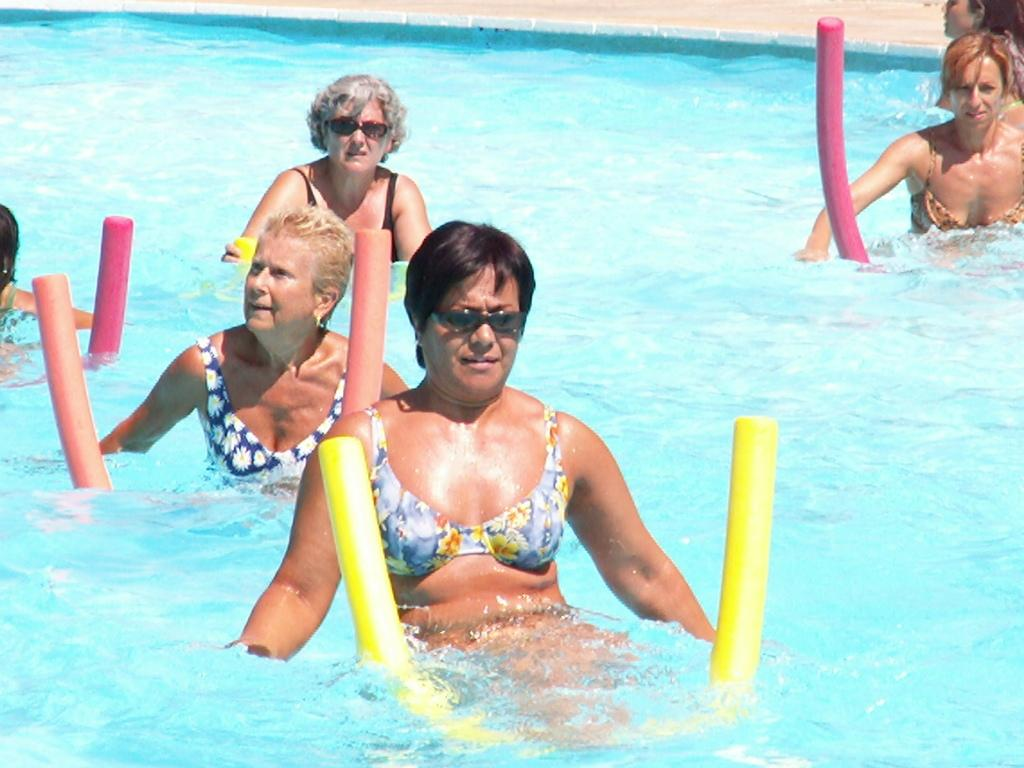What is the main element present in the image? There is water in the image. Are there any people in the image? Yes, there are people near the water. What other objects can be seen in the image? There are colored objects in the image. What is the surface on which the people and objects are situated? The ground is visible in the image. What type of wall can be seen in the image? There is no wall present in the image. How many people have died in the image? There is no indication of death or any such event in the image. 